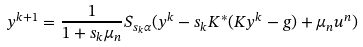<formula> <loc_0><loc_0><loc_500><loc_500>y ^ { k + 1 } = \frac { 1 } { 1 + s _ { k } \mu _ { n } } S _ { s _ { k } \alpha } ( y ^ { k } - s _ { k } K ^ { * } ( K y ^ { k } - g ) + \mu _ { n } u ^ { n } )</formula> 